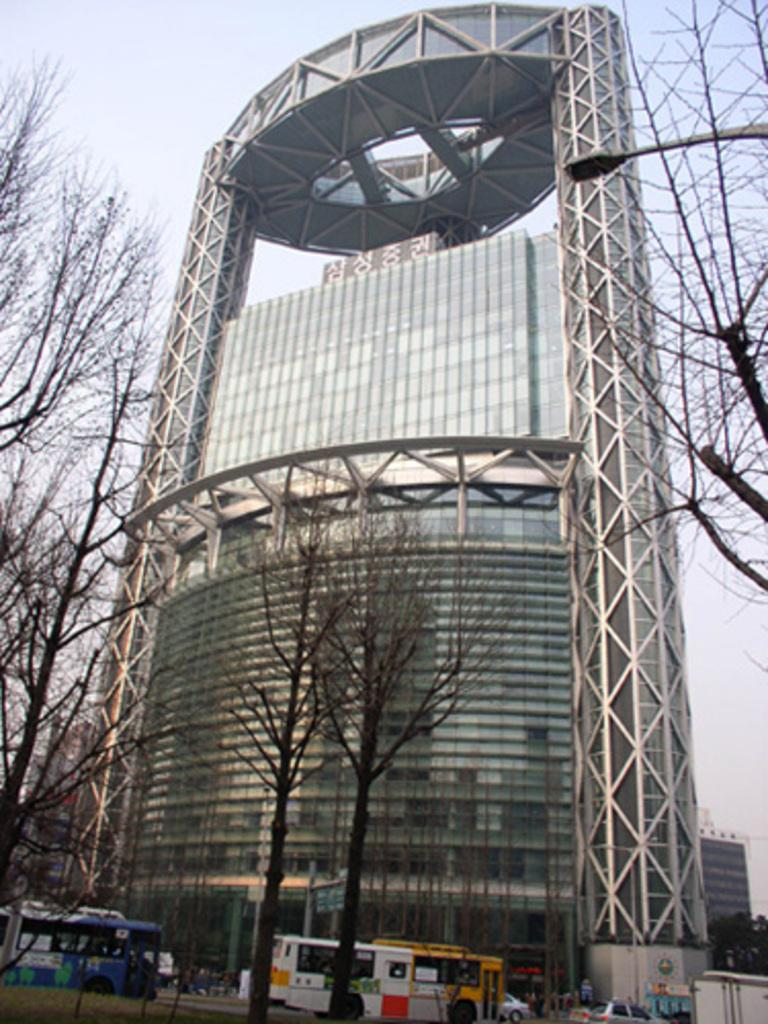What type of natural elements can be seen in the image? There are trees in the image. What mode of transportation is present on the road in the image? There are two buses and other vehicles on the road in the image. What type of infrastructure is present in the image? There is a street light and buildings in the image. What part of the natural environment is visible in the background of the image? The sky is visible in the background of the image. What type of brass instrument is being played by the trees in the image? There is no brass instrument present in the image, as it features trees, buses, vehicles, street lights, buildings, and the sky. What type of lock can be seen securing the sand in the image? There is no sand or lock present in the image. 